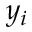Convert formula to latex. <formula><loc_0><loc_0><loc_500><loc_500>y _ { i }</formula> 